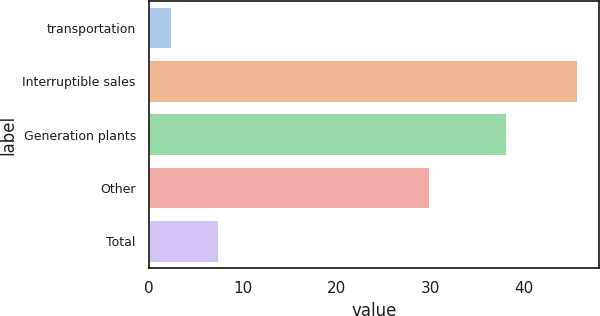Convert chart to OTSL. <chart><loc_0><loc_0><loc_500><loc_500><bar_chart><fcel>transportation<fcel>Interruptible sales<fcel>Generation plants<fcel>Other<fcel>Total<nl><fcel>2.5<fcel>45.7<fcel>38.2<fcel>30<fcel>7.5<nl></chart> 